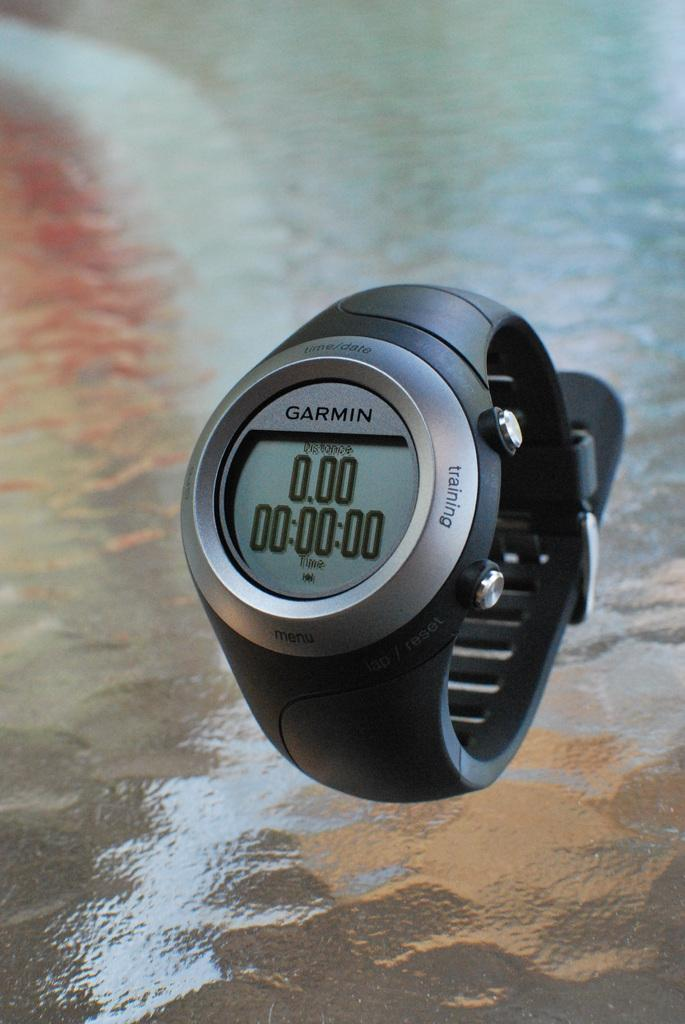<image>
Render a clear and concise summary of the photo. A black watch with silver around the face that says Garmin at the top. 